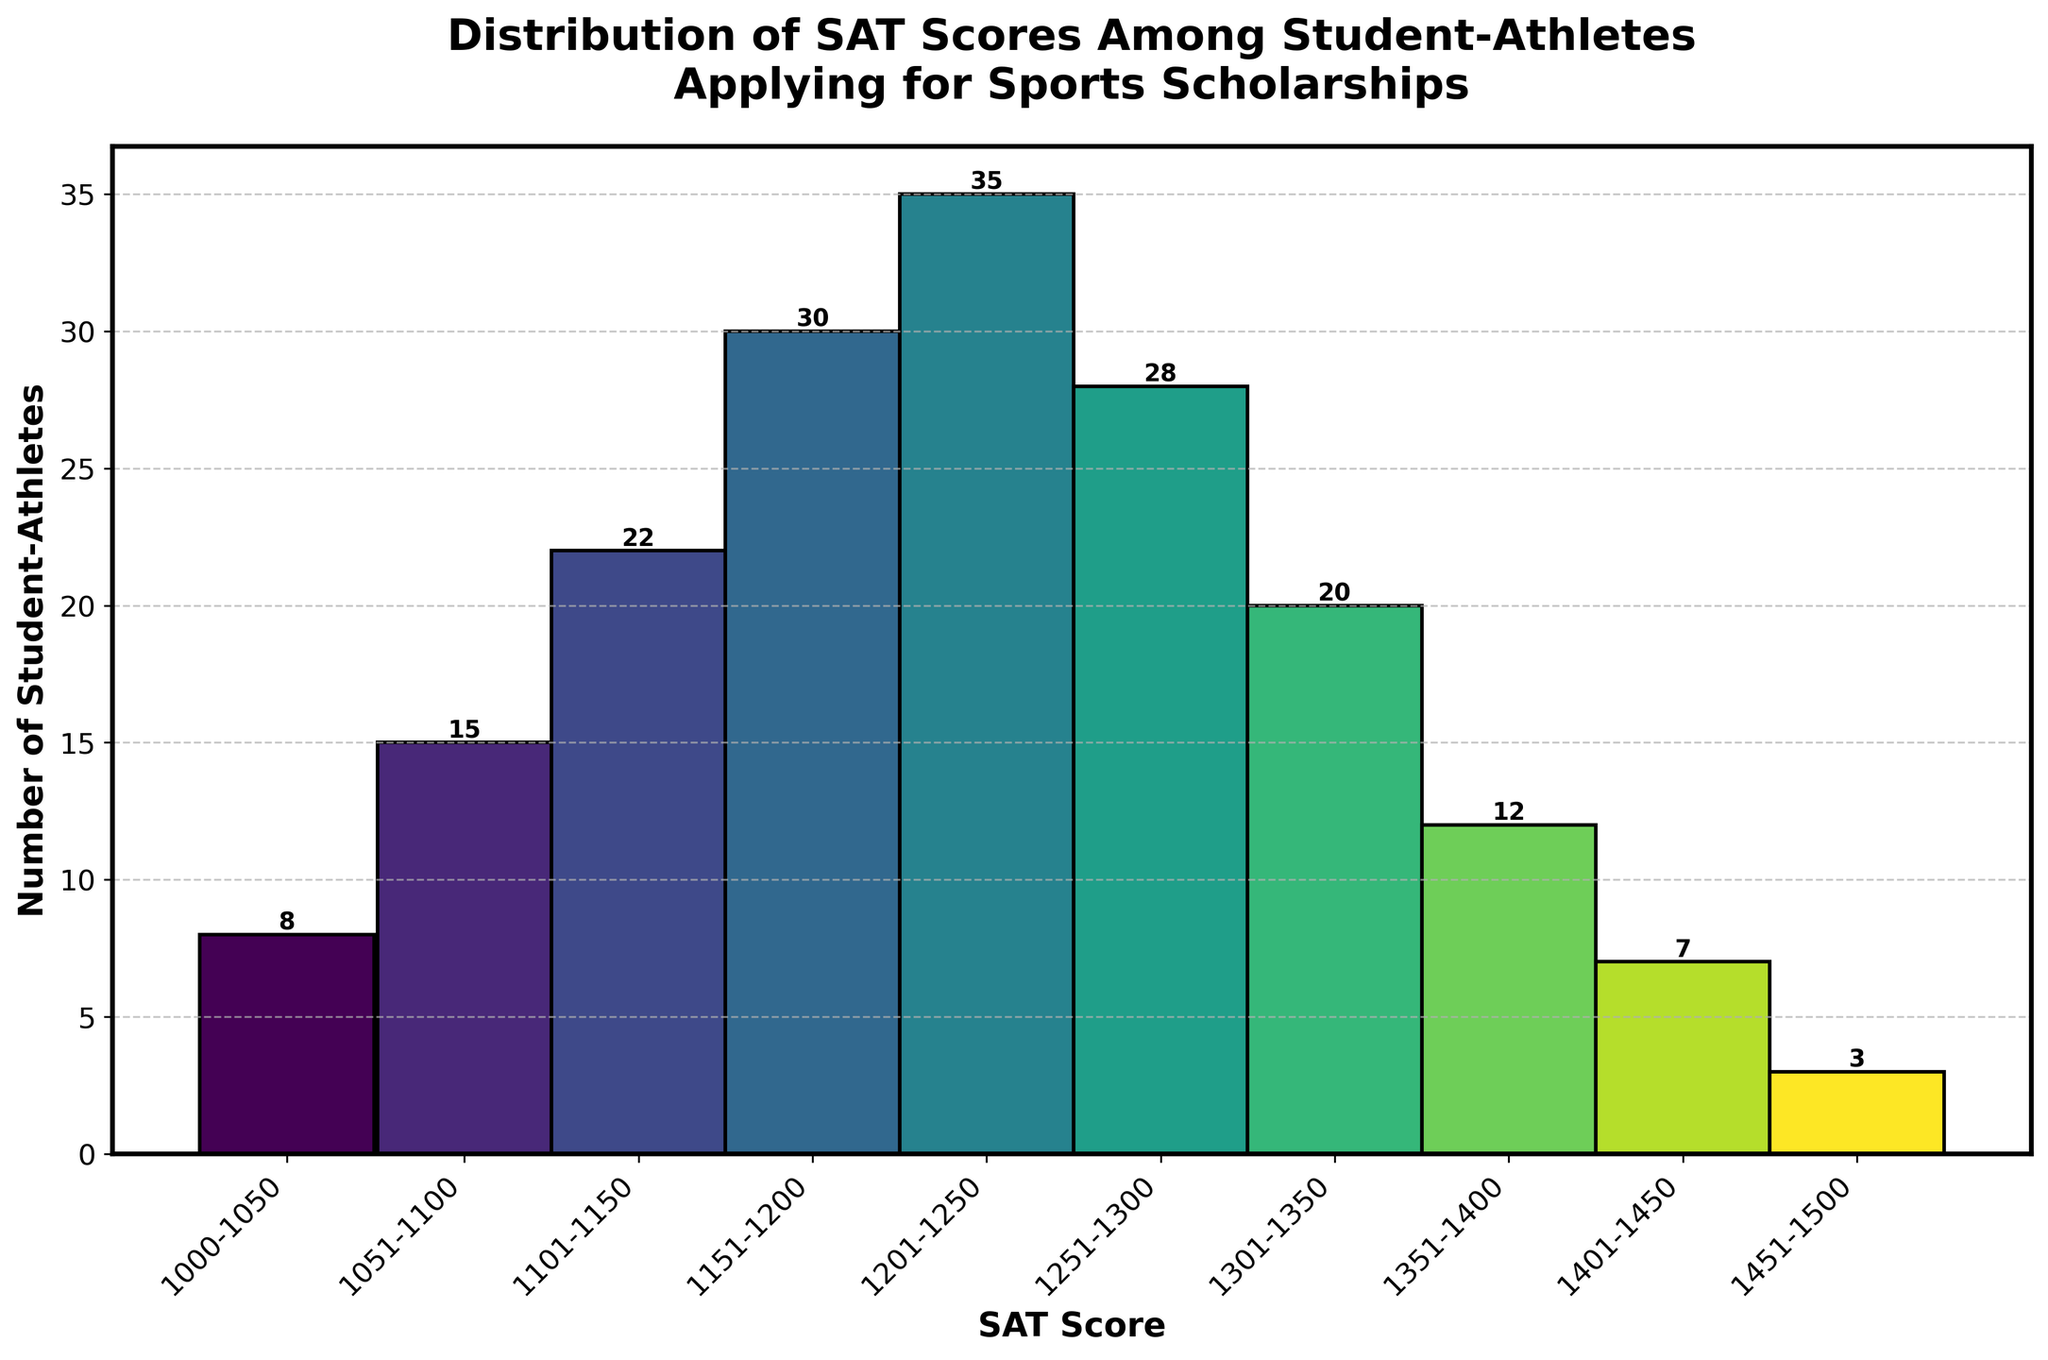What's the title of the histogram? The title of the histogram is located at the top of the figure and reads "Distribution of SAT Scores Among Student-Athletes Applying for Sports Scholarships". This directly describes what the visual information represents.
Answer: Distribution of SAT Scores Among Student-Athletes Applying for Sports Scholarships What does the x-axis represent? The x-axis represents the SAT Score ranges of the student-athletes applying for sports scholarships. This can be observed by looking at the labels along the horizontal axis of the histogram.
Answer: SAT Score ranges What is the total number of student-athletes represented in the histogram? To find the total number of student-athletes, we need to sum up the counts from each SAT score range. These counts are 8, 15, 22, 30, 35, 28, 20, 12, 7, and 3. Adding these together gives the total.
Answer: 180 Which SAT score range has the highest number of student-athletes? The bar with the greatest height or value label directly indicates the SAT score range with the highest number of student-athletes. In this histogram, the tallest bar is for the 1201-1250 range with a count of 35.
Answer: 1201-1250 How many student-athletes scored above 1300 on the SAT? To determine this, sum the counts for the SAT score ranges above 1300 (1301-1350, 1351-1400, 1401-1450, and 1451-1500). These bars have 20, 12, 7, and 3 student-athletes, respectively.
Answer: 42 Which SAT score range has the second lowest number of student-athletes? To find the second lowest, first identify the lowest, which is the 1451-1500 range with 3 student-athletes. The next lowest is 1401-1450 with 7 student-athletes.
Answer: 1401-1450 What is the total number of student-athletes with SAT scores between 1101 and 1250? Add the counts for the SAT score ranges 1101-1150, 1151-1200, and 1201-1250. These counts are 22, 30, and 35, respectively.
Answer: 87 How does the count of student-athletes scoring 1251-1300 compare to those scoring 1151-1200? Compare the heights (counts) of the two bars. The 1251-1300 range has 28, while the 1151-1200 range has 30.
Answer: Less by 2 Why might there be a peak in the distribution around the 1201-1250 range? This question requires inference based on the visual pattern. Possible reasons might include that this score range is a common threshold for scholarship qualification or a target score range for student-athletes aiming to balance academics and sports.
Answer: Common threshold or target score range for student-athletes aiming to balance academics and sports What is the most common score range for student-athletes applying for sports scholarships? The most common score range is shown by the bar with the highest count. In this histogram, it is the 1201-1250 range with 35 student-athletes.
Answer: 1201-1250 